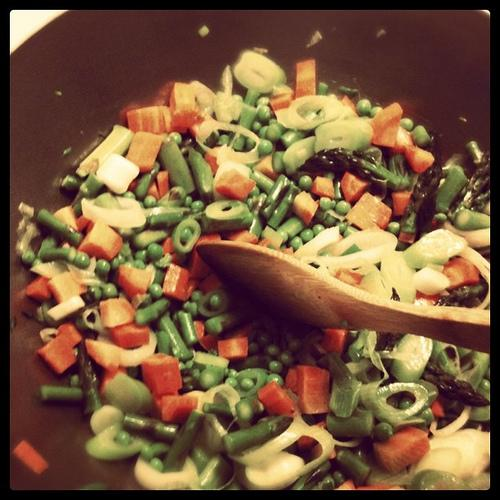Describe the lighting and shadows in the image. A light is shining on the plate of food, creating a shadow cast by the wooden spoon over the mixed vegetables. Compose a sentence that emphasizes the arrangement of the main components in the image. A flat, wooden spoon casts a shadow on a plate of mixed vegetables, which includes carrots, peas, green beans, onions, and asparagus, resting on a white table. Provide a short explanation of the main object and its purpose in the image. The central object is a brown wooden spoon, which is being used to mix together a plate of delectable mixed vegetables. List the main components of the image in the order of their importance. Plate of mixed vegetables, wooden spoon, carrots, peas, green beans, onions, asparagus, and white table. Write a brief statement that combines the main elements and their interactions in the image. The wooden spoon, held sideways, mixes together a variety of colorful vegetables on a brown plate, placed on a white surface. Write a sentence that highlights the action happening in the image. A wooden spoon is stirring a large plate of colorful mixed vegetables, creating an appetizing scene. Create an imaginative sentence that depicts the scene in the image. A symphony of colors bursts forth as a wooden spoon unites the vibrant vegetables in their dance on a brown plate atop a white stage. Using the given information, produce a sentence describing the colors and sizes of the objects in the image. The image features a large plate of variously sized vegetables in hues of green, orange, and white, being stirred by a flat wooden spoon. Write a brief summary of the overall color scheme and elements present in the image. The image is mainly comprised of vegetables like green peas, orange carrots, and green bean, on a brown plate over a white table, with a brown wooden spoon mixing the food. Using terms from the given information, create a concise description of the primary objects and their positioning in the image. There's a large plate of mixed vegetables on a white table, with carrots, peas, green beans, onions, and asparagus, being mixed together by a wooden spoon. 